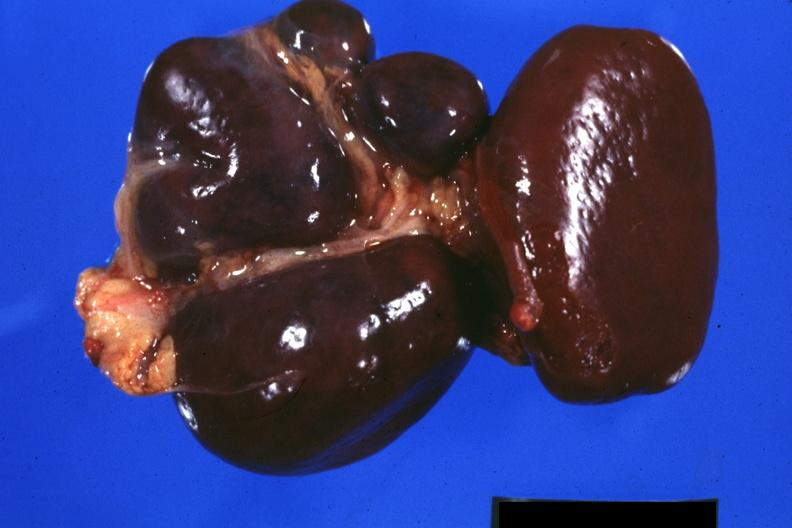s polysplenia present?
Answer the question using a single word or phrase. Yes 